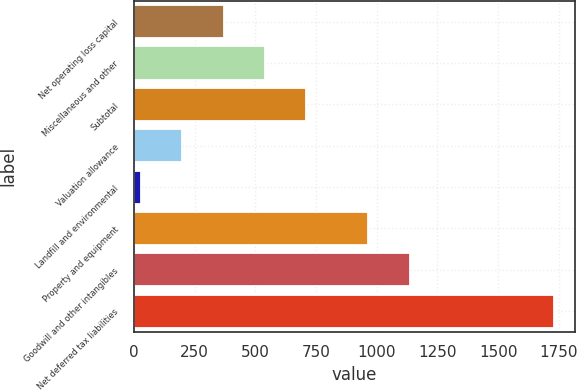Convert chart. <chart><loc_0><loc_0><loc_500><loc_500><bar_chart><fcel>Net operating loss capital<fcel>Miscellaneous and other<fcel>Subtotal<fcel>Valuation allowance<fcel>Landfill and environmental<fcel>Property and equipment<fcel>Goodwill and other intangibles<fcel>Net deferred tax liabilities<nl><fcel>369.8<fcel>539.7<fcel>709.6<fcel>199.9<fcel>30<fcel>966<fcel>1135.9<fcel>1729<nl></chart> 